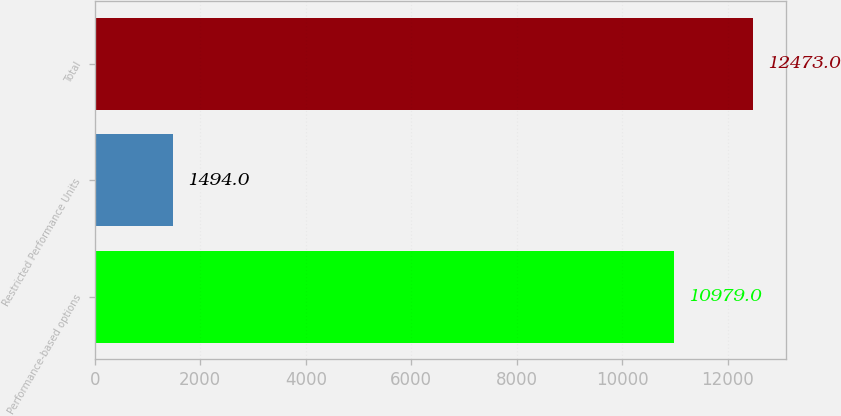Convert chart to OTSL. <chart><loc_0><loc_0><loc_500><loc_500><bar_chart><fcel>Performance-based options<fcel>Restricted Performance Units<fcel>Total<nl><fcel>10979<fcel>1494<fcel>12473<nl></chart> 